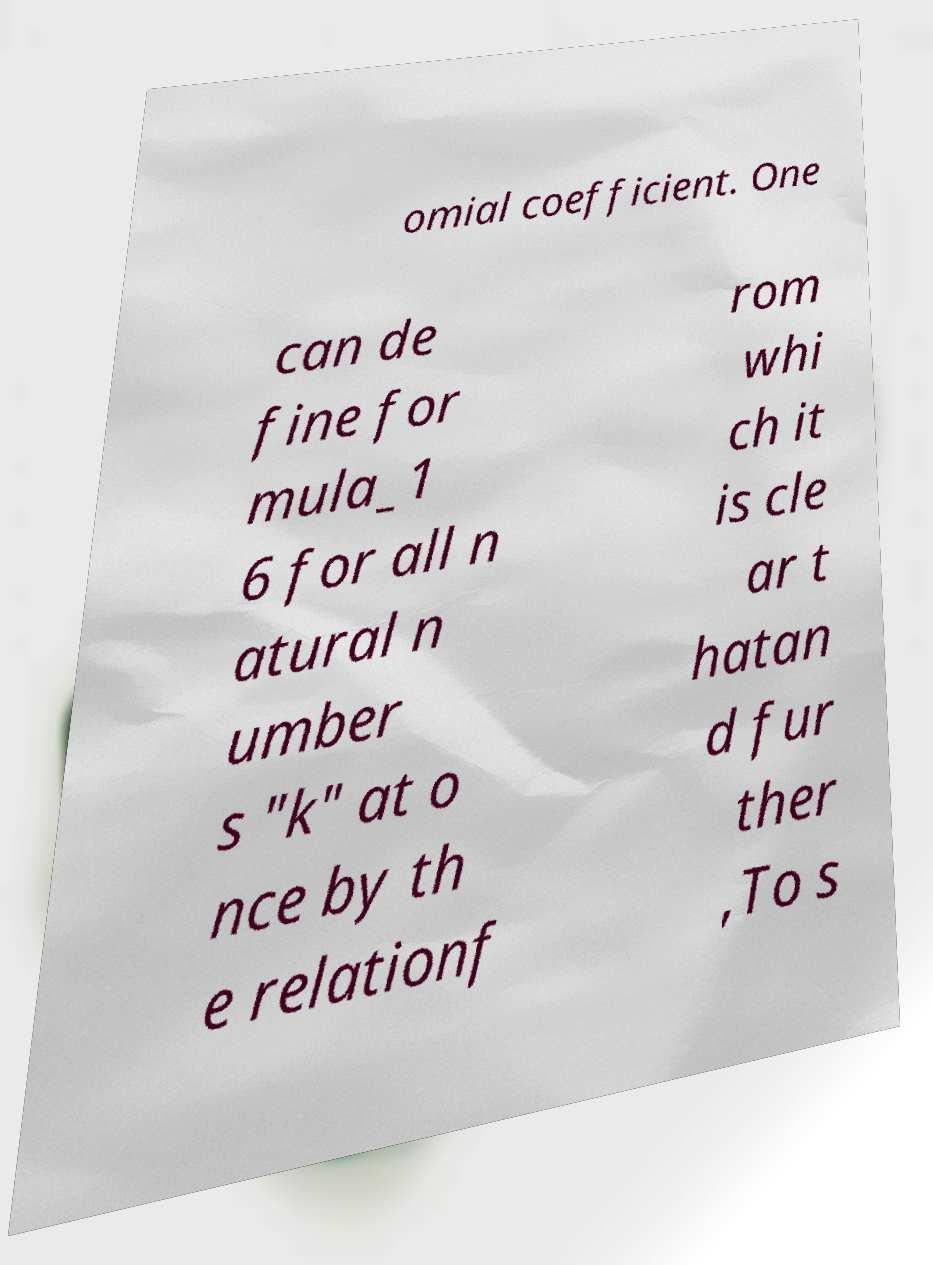Can you read and provide the text displayed in the image?This photo seems to have some interesting text. Can you extract and type it out for me? omial coefficient. One can de fine for mula_1 6 for all n atural n umber s "k" at o nce by th e relationf rom whi ch it is cle ar t hatan d fur ther ,To s 